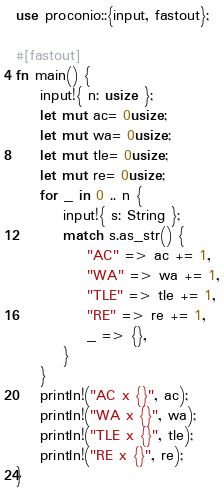Convert code to text. <code><loc_0><loc_0><loc_500><loc_500><_Rust_>use proconio::{input, fastout};

#[fastout]
fn main() {
    input!{ n: usize };
    let mut ac= 0usize;
    let mut wa= 0usize;
    let mut tle= 0usize;
    let mut re= 0usize;
    for _ in 0 .. n {
        input!{ s: String };
        match s.as_str() {
            "AC" => ac += 1,
            "WA" => wa += 1,
            "TLE" => tle += 1,
            "RE" => re += 1,
            _ => {},
        }
    }
    println!("AC x {}", ac);
    println!("WA x {}", wa);
    println!("TLE x {}", tle);
    println!("RE x {}", re);
}
</code> 